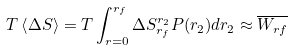<formula> <loc_0><loc_0><loc_500><loc_500>T \left \langle \Delta S \right \rangle = T \int _ { r = 0 } ^ { r _ { f } } \Delta S _ { r _ { f } } ^ { r _ { 2 } } P ( r _ { 2 } ) d r _ { 2 } \approx \overline { W _ { r f } }</formula> 